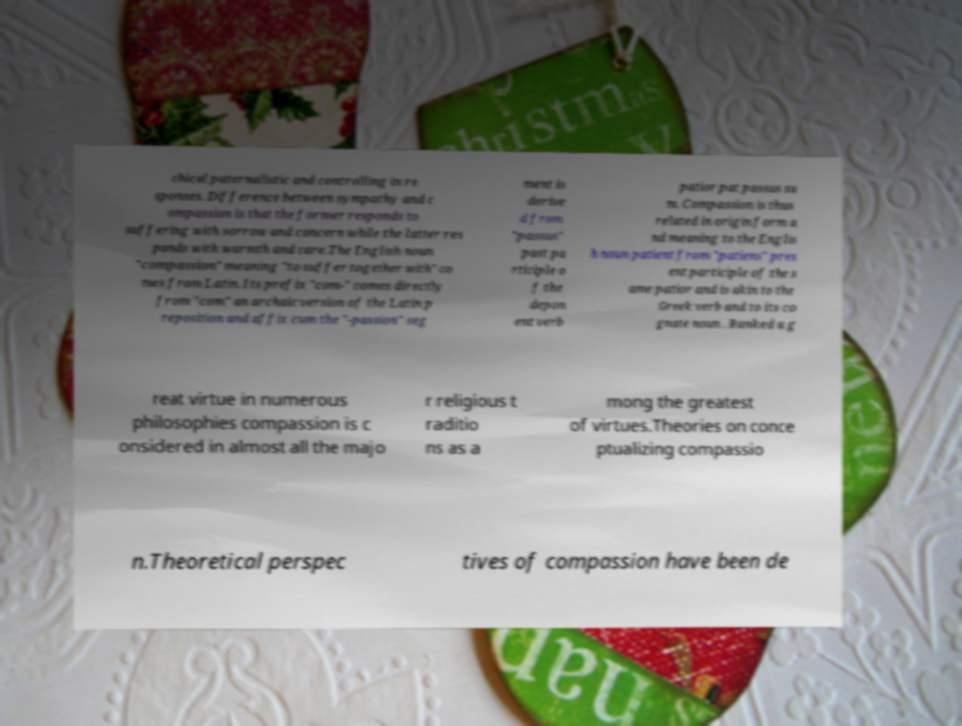Could you extract and type out the text from this image? chical paternalistic and controlling in re sponses. Difference between sympathy and c ompassion is that the former responds to suffering with sorrow and concern while the latter res ponds with warmth and care.The English noun "compassion" meaning "to suffer together with" co mes from Latin. Its prefix "com-" comes directly from "com" an archaic version of the Latin p reposition and affix cum the "-passion" seg ment is derive d from "passus" past pa rticiple o f the depon ent verb patior pat passus su m. Compassion is thus related in origin form a nd meaning to the Englis h noun patient from "patiens" pres ent participle of the s ame patior and is akin to the Greek verb and to its co gnate noun . Ranked a g reat virtue in numerous philosophies compassion is c onsidered in almost all the majo r religious t raditio ns as a mong the greatest of virtues.Theories on conce ptualizing compassio n.Theoretical perspec tives of compassion have been de 